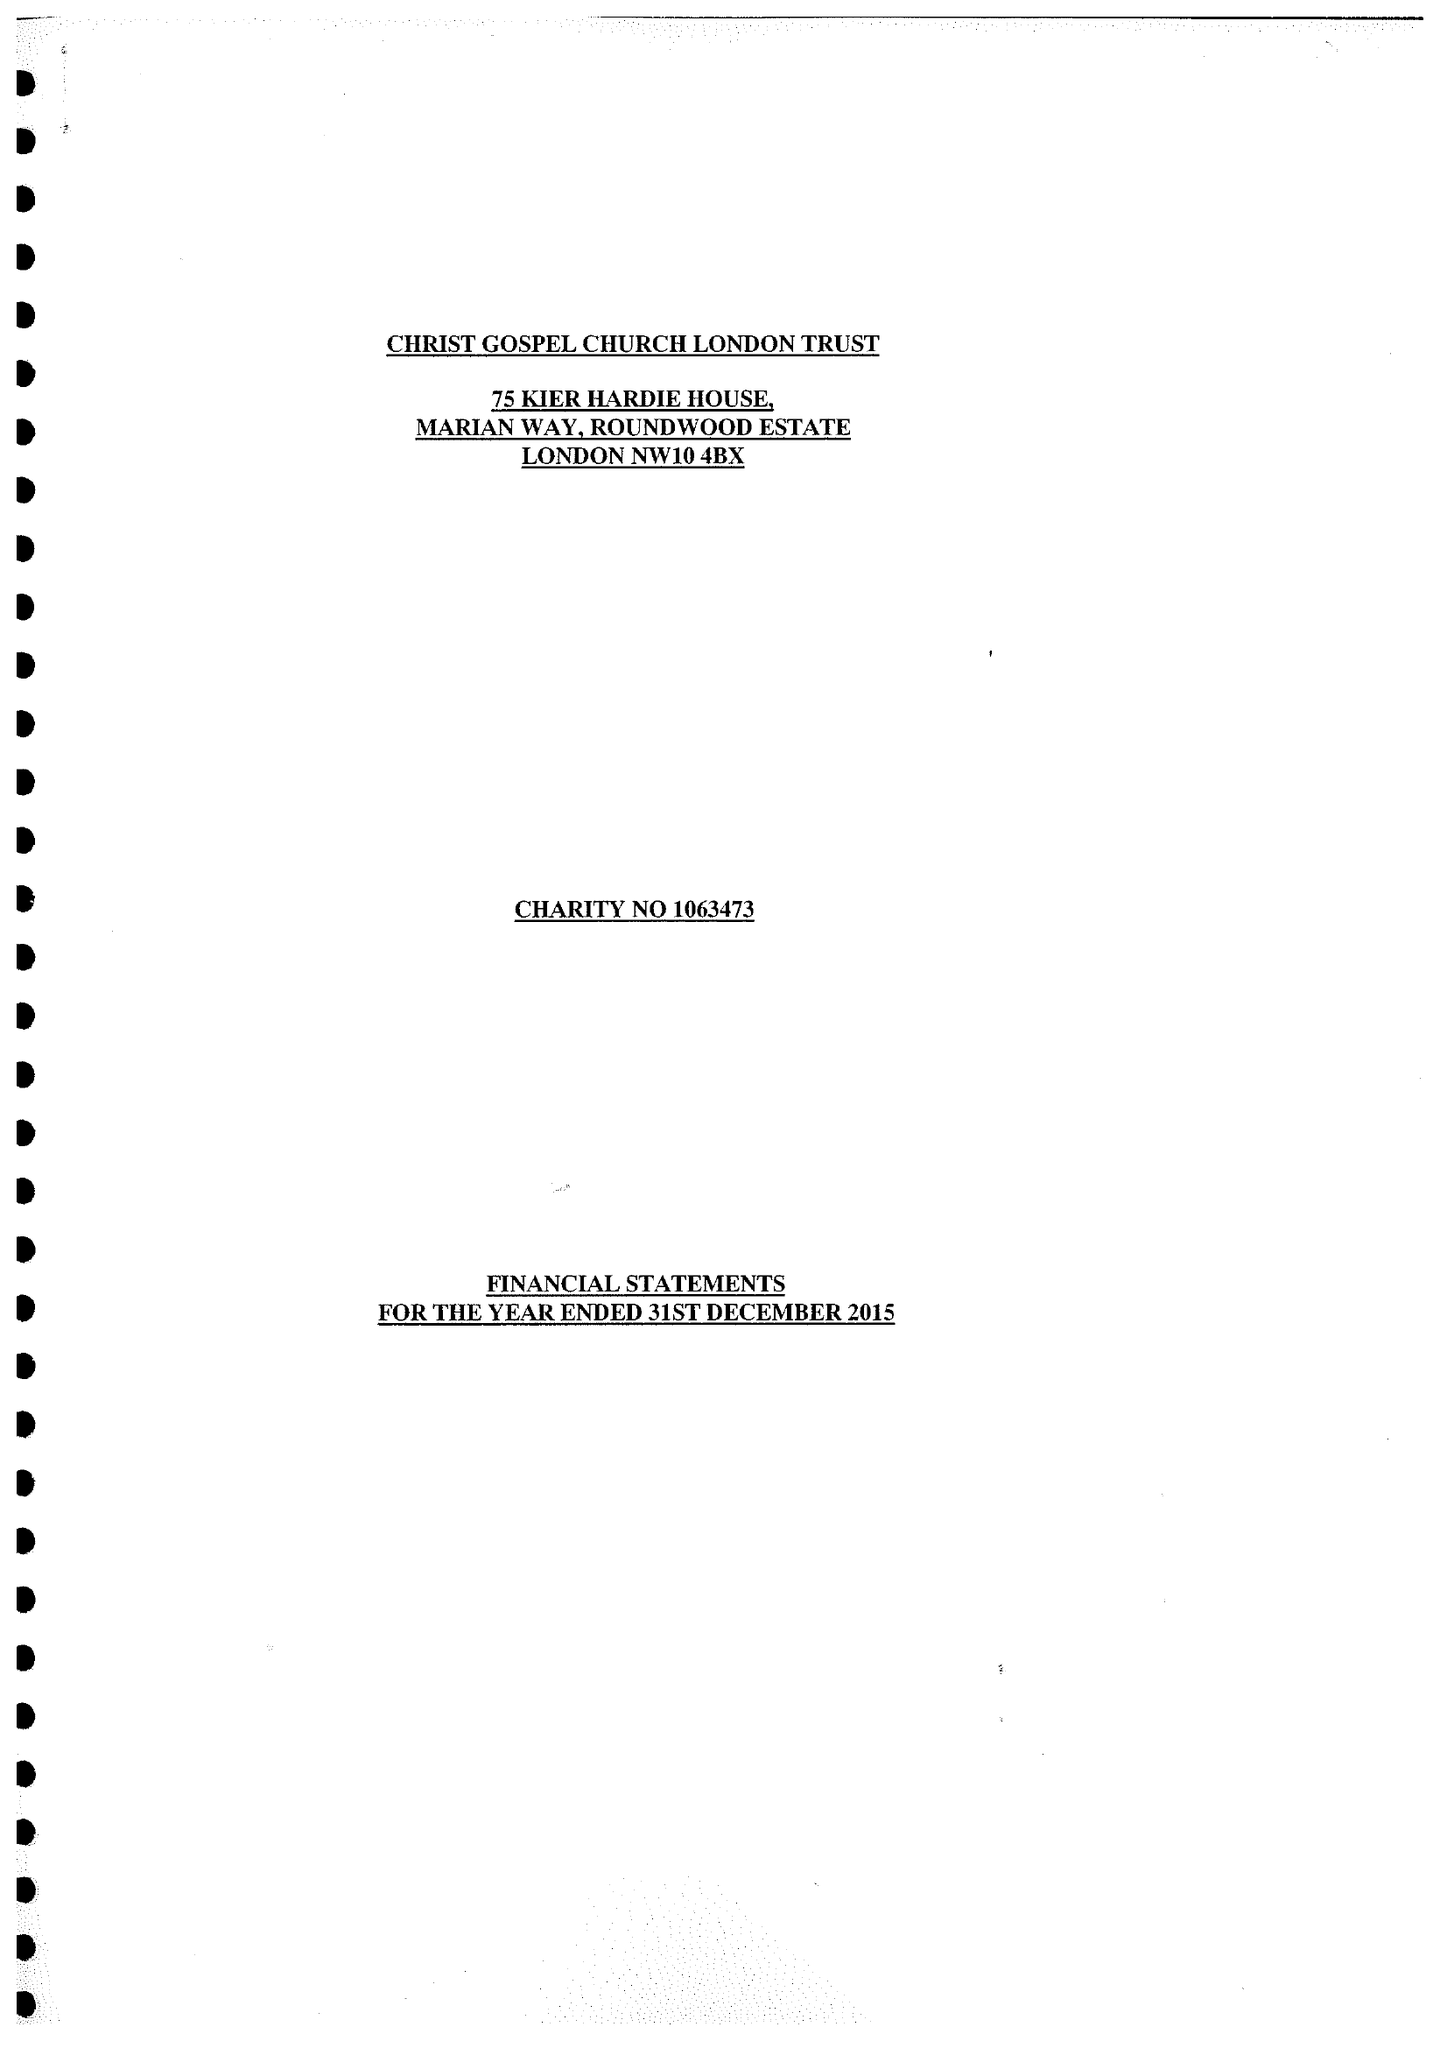What is the value for the address__post_town?
Answer the question using a single word or phrase. LONDON 